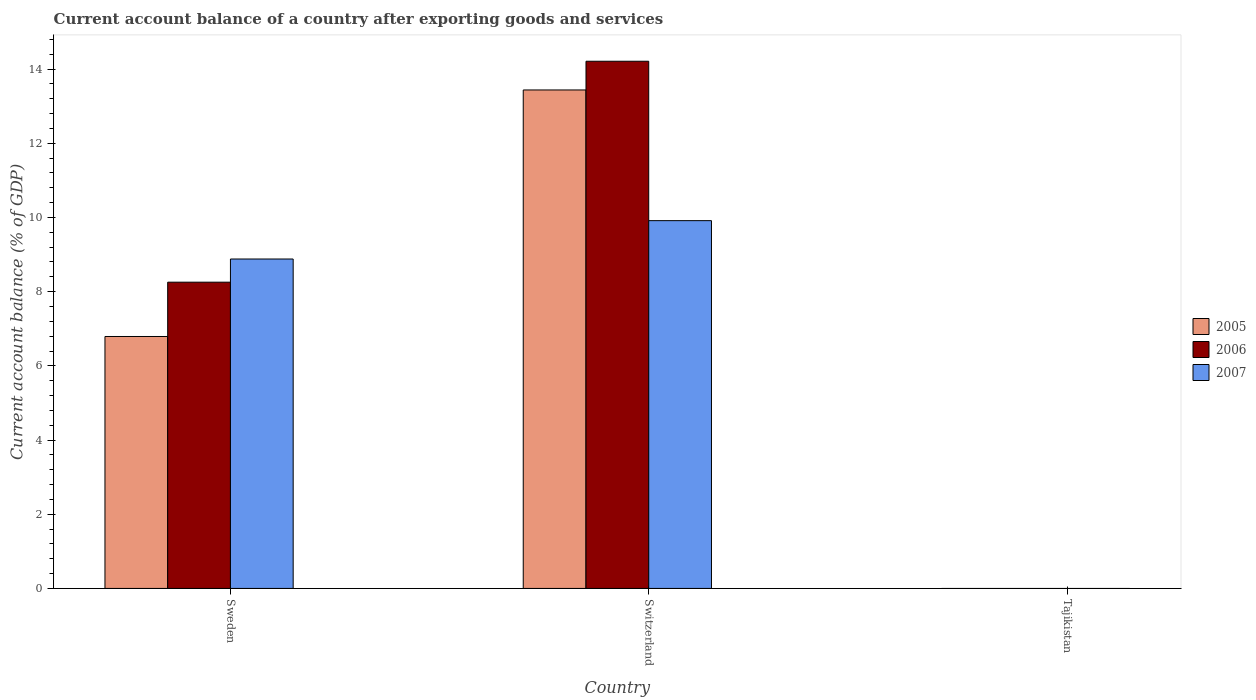Are the number of bars on each tick of the X-axis equal?
Your answer should be very brief. No. How many bars are there on the 3rd tick from the left?
Give a very brief answer. 0. In how many cases, is the number of bars for a given country not equal to the number of legend labels?
Offer a terse response. 1. Across all countries, what is the maximum account balance in 2005?
Give a very brief answer. 13.44. In which country was the account balance in 2006 maximum?
Make the answer very short. Switzerland. What is the total account balance in 2006 in the graph?
Keep it short and to the point. 22.47. What is the difference between the account balance in 2005 in Sweden and that in Switzerland?
Offer a very short reply. -6.65. What is the difference between the account balance in 2006 in Sweden and the account balance in 2005 in Tajikistan?
Provide a short and direct response. 8.26. What is the average account balance in 2006 per country?
Provide a short and direct response. 7.49. What is the difference between the account balance of/in 2007 and account balance of/in 2006 in Switzerland?
Give a very brief answer. -4.3. What is the ratio of the account balance in 2005 in Sweden to that in Switzerland?
Give a very brief answer. 0.51. What is the difference between the highest and the lowest account balance in 2005?
Offer a terse response. 13.44. In how many countries, is the account balance in 2005 greater than the average account balance in 2005 taken over all countries?
Provide a short and direct response. 2. Is the sum of the account balance in 2007 in Sweden and Switzerland greater than the maximum account balance in 2005 across all countries?
Ensure brevity in your answer.  Yes. Is it the case that in every country, the sum of the account balance in 2005 and account balance in 2006 is greater than the account balance in 2007?
Ensure brevity in your answer.  No. How many bars are there?
Your answer should be compact. 6. How many countries are there in the graph?
Your response must be concise. 3. What is the difference between two consecutive major ticks on the Y-axis?
Ensure brevity in your answer.  2. Does the graph contain any zero values?
Make the answer very short. Yes. Does the graph contain grids?
Your answer should be very brief. No. Where does the legend appear in the graph?
Your answer should be very brief. Center right. How many legend labels are there?
Provide a short and direct response. 3. What is the title of the graph?
Give a very brief answer. Current account balance of a country after exporting goods and services. Does "1976" appear as one of the legend labels in the graph?
Offer a terse response. No. What is the label or title of the X-axis?
Give a very brief answer. Country. What is the label or title of the Y-axis?
Your answer should be compact. Current account balance (% of GDP). What is the Current account balance (% of GDP) in 2005 in Sweden?
Your response must be concise. 6.79. What is the Current account balance (% of GDP) of 2006 in Sweden?
Give a very brief answer. 8.26. What is the Current account balance (% of GDP) in 2007 in Sweden?
Your answer should be very brief. 8.88. What is the Current account balance (% of GDP) of 2005 in Switzerland?
Keep it short and to the point. 13.44. What is the Current account balance (% of GDP) of 2006 in Switzerland?
Provide a short and direct response. 14.21. What is the Current account balance (% of GDP) of 2007 in Switzerland?
Give a very brief answer. 9.91. What is the Current account balance (% of GDP) of 2006 in Tajikistan?
Provide a short and direct response. 0. Across all countries, what is the maximum Current account balance (% of GDP) in 2005?
Give a very brief answer. 13.44. Across all countries, what is the maximum Current account balance (% of GDP) of 2006?
Offer a very short reply. 14.21. Across all countries, what is the maximum Current account balance (% of GDP) in 2007?
Your answer should be compact. 9.91. Across all countries, what is the minimum Current account balance (% of GDP) of 2007?
Ensure brevity in your answer.  0. What is the total Current account balance (% of GDP) in 2005 in the graph?
Provide a succinct answer. 20.23. What is the total Current account balance (% of GDP) in 2006 in the graph?
Your answer should be compact. 22.47. What is the total Current account balance (% of GDP) of 2007 in the graph?
Give a very brief answer. 18.79. What is the difference between the Current account balance (% of GDP) in 2005 in Sweden and that in Switzerland?
Offer a terse response. -6.65. What is the difference between the Current account balance (% of GDP) in 2006 in Sweden and that in Switzerland?
Give a very brief answer. -5.96. What is the difference between the Current account balance (% of GDP) in 2007 in Sweden and that in Switzerland?
Offer a very short reply. -1.03. What is the difference between the Current account balance (% of GDP) in 2005 in Sweden and the Current account balance (% of GDP) in 2006 in Switzerland?
Your response must be concise. -7.42. What is the difference between the Current account balance (% of GDP) of 2005 in Sweden and the Current account balance (% of GDP) of 2007 in Switzerland?
Offer a terse response. -3.12. What is the difference between the Current account balance (% of GDP) in 2006 in Sweden and the Current account balance (% of GDP) in 2007 in Switzerland?
Your answer should be compact. -1.66. What is the average Current account balance (% of GDP) in 2005 per country?
Offer a terse response. 6.74. What is the average Current account balance (% of GDP) of 2006 per country?
Keep it short and to the point. 7.49. What is the average Current account balance (% of GDP) of 2007 per country?
Make the answer very short. 6.26. What is the difference between the Current account balance (% of GDP) of 2005 and Current account balance (% of GDP) of 2006 in Sweden?
Your response must be concise. -1.46. What is the difference between the Current account balance (% of GDP) in 2005 and Current account balance (% of GDP) in 2007 in Sweden?
Provide a short and direct response. -2.09. What is the difference between the Current account balance (% of GDP) in 2006 and Current account balance (% of GDP) in 2007 in Sweden?
Offer a terse response. -0.62. What is the difference between the Current account balance (% of GDP) in 2005 and Current account balance (% of GDP) in 2006 in Switzerland?
Make the answer very short. -0.77. What is the difference between the Current account balance (% of GDP) of 2005 and Current account balance (% of GDP) of 2007 in Switzerland?
Your answer should be very brief. 3.52. What is the difference between the Current account balance (% of GDP) in 2006 and Current account balance (% of GDP) in 2007 in Switzerland?
Provide a short and direct response. 4.3. What is the ratio of the Current account balance (% of GDP) in 2005 in Sweden to that in Switzerland?
Your response must be concise. 0.51. What is the ratio of the Current account balance (% of GDP) in 2006 in Sweden to that in Switzerland?
Your response must be concise. 0.58. What is the ratio of the Current account balance (% of GDP) in 2007 in Sweden to that in Switzerland?
Offer a terse response. 0.9. What is the difference between the highest and the lowest Current account balance (% of GDP) in 2005?
Your answer should be compact. 13.44. What is the difference between the highest and the lowest Current account balance (% of GDP) of 2006?
Offer a very short reply. 14.21. What is the difference between the highest and the lowest Current account balance (% of GDP) in 2007?
Offer a terse response. 9.91. 